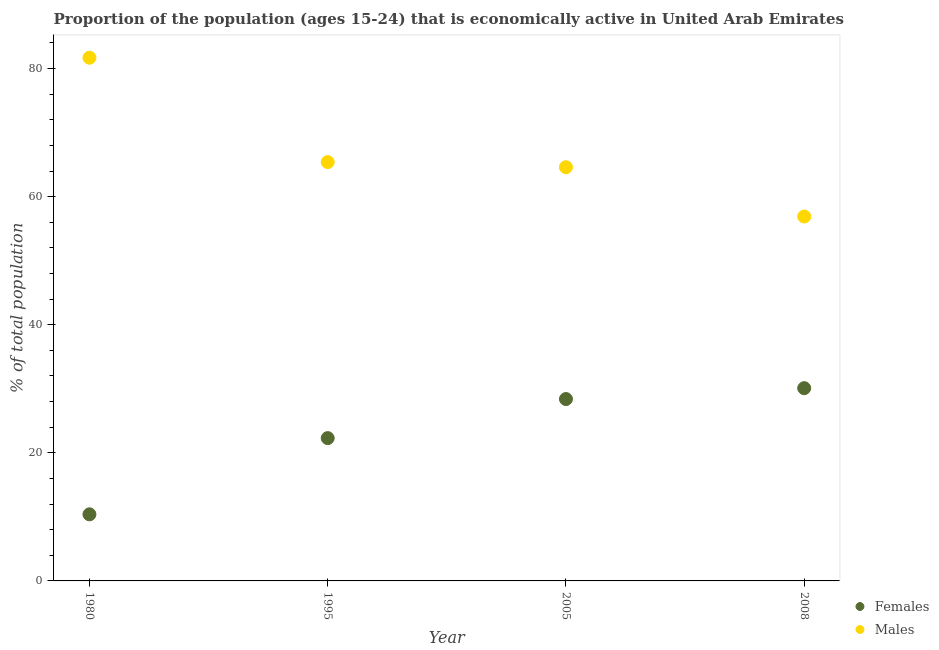Is the number of dotlines equal to the number of legend labels?
Give a very brief answer. Yes. What is the percentage of economically active female population in 1995?
Your answer should be compact. 22.3. Across all years, what is the maximum percentage of economically active female population?
Give a very brief answer. 30.1. Across all years, what is the minimum percentage of economically active male population?
Offer a terse response. 56.9. In which year was the percentage of economically active male population maximum?
Give a very brief answer. 1980. What is the total percentage of economically active male population in the graph?
Keep it short and to the point. 268.6. What is the difference between the percentage of economically active female population in 2005 and that in 2008?
Give a very brief answer. -1.7. What is the difference between the percentage of economically active female population in 1995 and the percentage of economically active male population in 2008?
Offer a terse response. -34.6. What is the average percentage of economically active male population per year?
Your answer should be very brief. 67.15. In the year 1980, what is the difference between the percentage of economically active female population and percentage of economically active male population?
Make the answer very short. -71.3. In how many years, is the percentage of economically active female population greater than 60 %?
Make the answer very short. 0. What is the ratio of the percentage of economically active female population in 1995 to that in 2005?
Offer a very short reply. 0.79. Is the percentage of economically active female population in 1980 less than that in 2005?
Ensure brevity in your answer.  Yes. What is the difference between the highest and the second highest percentage of economically active male population?
Offer a terse response. 16.3. What is the difference between the highest and the lowest percentage of economically active male population?
Your response must be concise. 24.8. Is the sum of the percentage of economically active female population in 1995 and 2008 greater than the maximum percentage of economically active male population across all years?
Offer a very short reply. No. What is the difference between two consecutive major ticks on the Y-axis?
Provide a succinct answer. 20. Are the values on the major ticks of Y-axis written in scientific E-notation?
Your answer should be compact. No. Does the graph contain grids?
Your answer should be very brief. No. Where does the legend appear in the graph?
Your answer should be very brief. Bottom right. How many legend labels are there?
Your answer should be compact. 2. What is the title of the graph?
Ensure brevity in your answer.  Proportion of the population (ages 15-24) that is economically active in United Arab Emirates. Does "Quality of trade" appear as one of the legend labels in the graph?
Keep it short and to the point. No. What is the label or title of the Y-axis?
Ensure brevity in your answer.  % of total population. What is the % of total population of Females in 1980?
Provide a short and direct response. 10.4. What is the % of total population of Males in 1980?
Your response must be concise. 81.7. What is the % of total population of Females in 1995?
Offer a terse response. 22.3. What is the % of total population in Males in 1995?
Ensure brevity in your answer.  65.4. What is the % of total population in Females in 2005?
Your response must be concise. 28.4. What is the % of total population of Males in 2005?
Provide a succinct answer. 64.6. What is the % of total population in Females in 2008?
Provide a succinct answer. 30.1. What is the % of total population in Males in 2008?
Keep it short and to the point. 56.9. Across all years, what is the maximum % of total population in Females?
Provide a succinct answer. 30.1. Across all years, what is the maximum % of total population of Males?
Your answer should be compact. 81.7. Across all years, what is the minimum % of total population of Females?
Make the answer very short. 10.4. Across all years, what is the minimum % of total population of Males?
Provide a succinct answer. 56.9. What is the total % of total population of Females in the graph?
Provide a short and direct response. 91.2. What is the total % of total population in Males in the graph?
Your answer should be very brief. 268.6. What is the difference between the % of total population in Females in 1980 and that in 1995?
Offer a terse response. -11.9. What is the difference between the % of total population in Males in 1980 and that in 1995?
Provide a short and direct response. 16.3. What is the difference between the % of total population in Females in 1980 and that in 2005?
Provide a short and direct response. -18. What is the difference between the % of total population of Males in 1980 and that in 2005?
Your answer should be very brief. 17.1. What is the difference between the % of total population of Females in 1980 and that in 2008?
Offer a terse response. -19.7. What is the difference between the % of total population of Males in 1980 and that in 2008?
Make the answer very short. 24.8. What is the difference between the % of total population in Females in 1995 and that in 2005?
Provide a succinct answer. -6.1. What is the difference between the % of total population of Males in 1995 and that in 2005?
Provide a succinct answer. 0.8. What is the difference between the % of total population of Females in 2005 and that in 2008?
Offer a very short reply. -1.7. What is the difference between the % of total population of Males in 2005 and that in 2008?
Provide a succinct answer. 7.7. What is the difference between the % of total population of Females in 1980 and the % of total population of Males in 1995?
Provide a succinct answer. -55. What is the difference between the % of total population in Females in 1980 and the % of total population in Males in 2005?
Ensure brevity in your answer.  -54.2. What is the difference between the % of total population of Females in 1980 and the % of total population of Males in 2008?
Provide a short and direct response. -46.5. What is the difference between the % of total population of Females in 1995 and the % of total population of Males in 2005?
Provide a short and direct response. -42.3. What is the difference between the % of total population in Females in 1995 and the % of total population in Males in 2008?
Your answer should be very brief. -34.6. What is the difference between the % of total population in Females in 2005 and the % of total population in Males in 2008?
Provide a succinct answer. -28.5. What is the average % of total population in Females per year?
Provide a succinct answer. 22.8. What is the average % of total population in Males per year?
Your response must be concise. 67.15. In the year 1980, what is the difference between the % of total population in Females and % of total population in Males?
Your answer should be compact. -71.3. In the year 1995, what is the difference between the % of total population of Females and % of total population of Males?
Make the answer very short. -43.1. In the year 2005, what is the difference between the % of total population of Females and % of total population of Males?
Provide a succinct answer. -36.2. In the year 2008, what is the difference between the % of total population of Females and % of total population of Males?
Make the answer very short. -26.8. What is the ratio of the % of total population of Females in 1980 to that in 1995?
Offer a very short reply. 0.47. What is the ratio of the % of total population of Males in 1980 to that in 1995?
Provide a succinct answer. 1.25. What is the ratio of the % of total population of Females in 1980 to that in 2005?
Keep it short and to the point. 0.37. What is the ratio of the % of total population in Males in 1980 to that in 2005?
Offer a terse response. 1.26. What is the ratio of the % of total population in Females in 1980 to that in 2008?
Your answer should be very brief. 0.35. What is the ratio of the % of total population in Males in 1980 to that in 2008?
Your answer should be compact. 1.44. What is the ratio of the % of total population of Females in 1995 to that in 2005?
Your answer should be compact. 0.79. What is the ratio of the % of total population in Males in 1995 to that in 2005?
Your answer should be compact. 1.01. What is the ratio of the % of total population of Females in 1995 to that in 2008?
Make the answer very short. 0.74. What is the ratio of the % of total population of Males in 1995 to that in 2008?
Your answer should be compact. 1.15. What is the ratio of the % of total population of Females in 2005 to that in 2008?
Your answer should be compact. 0.94. What is the ratio of the % of total population in Males in 2005 to that in 2008?
Offer a very short reply. 1.14. What is the difference between the highest and the second highest % of total population in Females?
Your response must be concise. 1.7. What is the difference between the highest and the lowest % of total population in Males?
Ensure brevity in your answer.  24.8. 